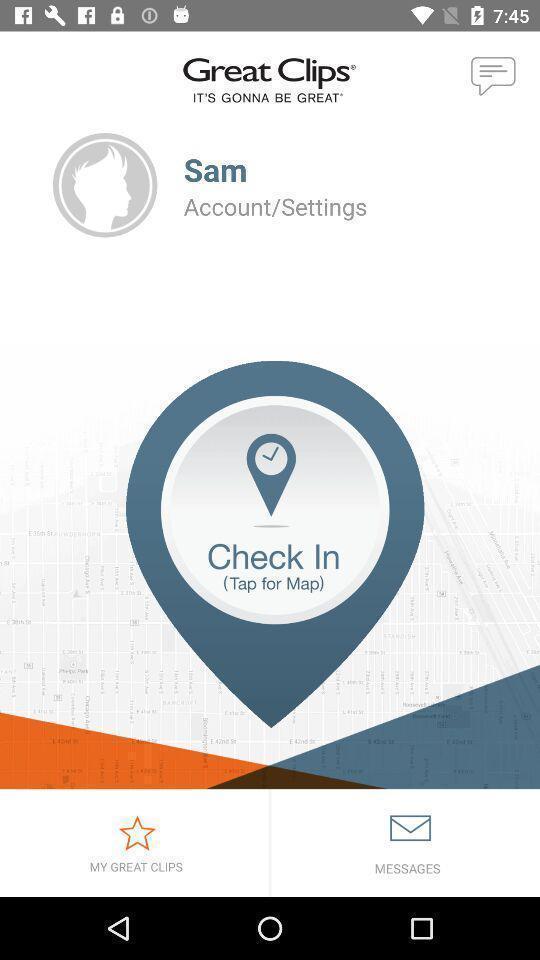Summarize the information in this screenshot. Welcome page. 